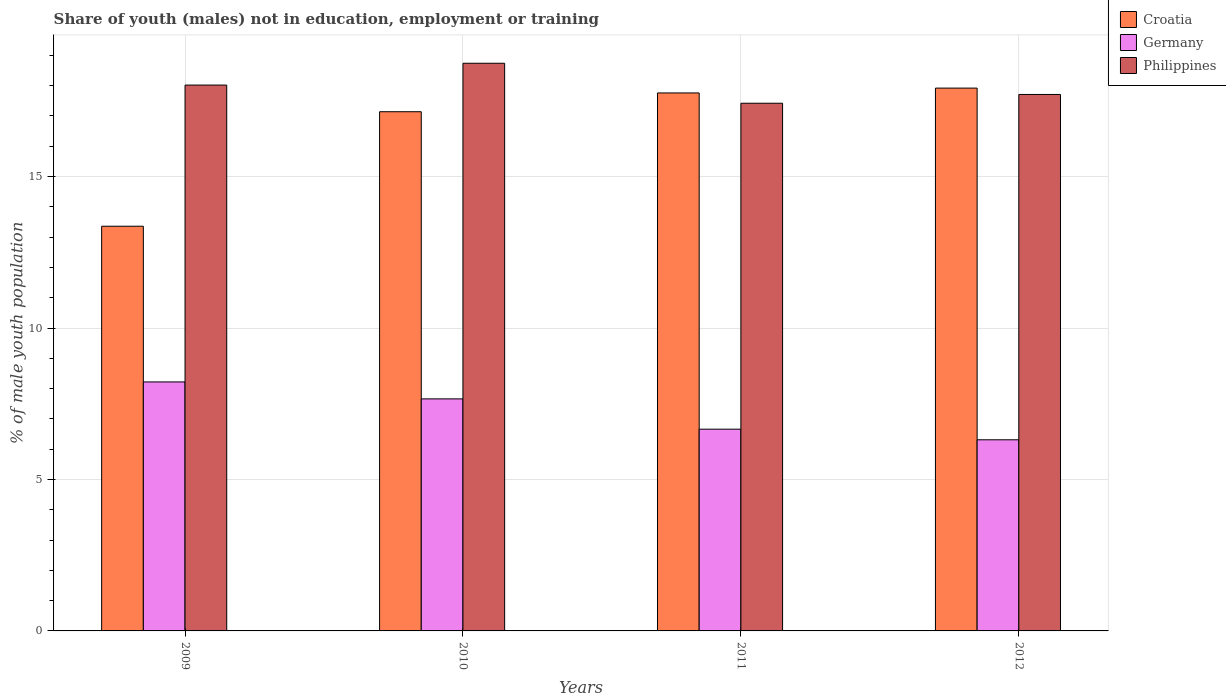Are the number of bars on each tick of the X-axis equal?
Make the answer very short. Yes. How many bars are there on the 3rd tick from the left?
Your answer should be compact. 3. In how many cases, is the number of bars for a given year not equal to the number of legend labels?
Give a very brief answer. 0. What is the percentage of unemployed males population in in Croatia in 2010?
Make the answer very short. 17.14. Across all years, what is the maximum percentage of unemployed males population in in Croatia?
Keep it short and to the point. 17.92. Across all years, what is the minimum percentage of unemployed males population in in Philippines?
Your answer should be compact. 17.42. In which year was the percentage of unemployed males population in in Philippines maximum?
Your answer should be compact. 2010. In which year was the percentage of unemployed males population in in Croatia minimum?
Provide a short and direct response. 2009. What is the total percentage of unemployed males population in in Croatia in the graph?
Provide a succinct answer. 66.18. What is the difference between the percentage of unemployed males population in in Philippines in 2010 and that in 2011?
Give a very brief answer. 1.32. What is the difference between the percentage of unemployed males population in in Croatia in 2011 and the percentage of unemployed males population in in Germany in 2010?
Give a very brief answer. 10.1. What is the average percentage of unemployed males population in in Philippines per year?
Provide a succinct answer. 17.97. In the year 2011, what is the difference between the percentage of unemployed males population in in Germany and percentage of unemployed males population in in Philippines?
Provide a short and direct response. -10.76. What is the ratio of the percentage of unemployed males population in in Croatia in 2009 to that in 2011?
Give a very brief answer. 0.75. Is the difference between the percentage of unemployed males population in in Germany in 2009 and 2010 greater than the difference between the percentage of unemployed males population in in Philippines in 2009 and 2010?
Provide a succinct answer. Yes. What is the difference between the highest and the second highest percentage of unemployed males population in in Germany?
Make the answer very short. 0.56. What is the difference between the highest and the lowest percentage of unemployed males population in in Croatia?
Keep it short and to the point. 4.56. What does the 3rd bar from the right in 2012 represents?
Offer a very short reply. Croatia. How many bars are there?
Offer a very short reply. 12. Are all the bars in the graph horizontal?
Your response must be concise. No. How many years are there in the graph?
Your answer should be very brief. 4. What is the difference between two consecutive major ticks on the Y-axis?
Your answer should be compact. 5. Does the graph contain grids?
Offer a terse response. Yes. Where does the legend appear in the graph?
Offer a very short reply. Top right. How many legend labels are there?
Offer a very short reply. 3. How are the legend labels stacked?
Provide a succinct answer. Vertical. What is the title of the graph?
Make the answer very short. Share of youth (males) not in education, employment or training. What is the label or title of the X-axis?
Ensure brevity in your answer.  Years. What is the label or title of the Y-axis?
Offer a very short reply. % of male youth population. What is the % of male youth population in Croatia in 2009?
Offer a very short reply. 13.36. What is the % of male youth population of Germany in 2009?
Your answer should be very brief. 8.22. What is the % of male youth population of Philippines in 2009?
Offer a very short reply. 18.02. What is the % of male youth population of Croatia in 2010?
Offer a very short reply. 17.14. What is the % of male youth population in Germany in 2010?
Your answer should be very brief. 7.66. What is the % of male youth population of Philippines in 2010?
Keep it short and to the point. 18.74. What is the % of male youth population of Croatia in 2011?
Give a very brief answer. 17.76. What is the % of male youth population in Germany in 2011?
Offer a very short reply. 6.66. What is the % of male youth population in Philippines in 2011?
Offer a terse response. 17.42. What is the % of male youth population of Croatia in 2012?
Offer a very short reply. 17.92. What is the % of male youth population of Germany in 2012?
Provide a short and direct response. 6.31. What is the % of male youth population in Philippines in 2012?
Ensure brevity in your answer.  17.71. Across all years, what is the maximum % of male youth population of Croatia?
Make the answer very short. 17.92. Across all years, what is the maximum % of male youth population of Germany?
Give a very brief answer. 8.22. Across all years, what is the maximum % of male youth population of Philippines?
Your answer should be compact. 18.74. Across all years, what is the minimum % of male youth population in Croatia?
Ensure brevity in your answer.  13.36. Across all years, what is the minimum % of male youth population in Germany?
Provide a short and direct response. 6.31. Across all years, what is the minimum % of male youth population in Philippines?
Give a very brief answer. 17.42. What is the total % of male youth population of Croatia in the graph?
Give a very brief answer. 66.18. What is the total % of male youth population in Germany in the graph?
Provide a short and direct response. 28.85. What is the total % of male youth population in Philippines in the graph?
Your answer should be very brief. 71.89. What is the difference between the % of male youth population in Croatia in 2009 and that in 2010?
Ensure brevity in your answer.  -3.78. What is the difference between the % of male youth population in Germany in 2009 and that in 2010?
Offer a terse response. 0.56. What is the difference between the % of male youth population in Philippines in 2009 and that in 2010?
Offer a terse response. -0.72. What is the difference between the % of male youth population of Croatia in 2009 and that in 2011?
Offer a terse response. -4.4. What is the difference between the % of male youth population of Germany in 2009 and that in 2011?
Your answer should be compact. 1.56. What is the difference between the % of male youth population in Philippines in 2009 and that in 2011?
Give a very brief answer. 0.6. What is the difference between the % of male youth population of Croatia in 2009 and that in 2012?
Provide a short and direct response. -4.56. What is the difference between the % of male youth population of Germany in 2009 and that in 2012?
Your answer should be very brief. 1.91. What is the difference between the % of male youth population in Philippines in 2009 and that in 2012?
Offer a very short reply. 0.31. What is the difference between the % of male youth population of Croatia in 2010 and that in 2011?
Ensure brevity in your answer.  -0.62. What is the difference between the % of male youth population in Germany in 2010 and that in 2011?
Your answer should be compact. 1. What is the difference between the % of male youth population in Philippines in 2010 and that in 2011?
Make the answer very short. 1.32. What is the difference between the % of male youth population of Croatia in 2010 and that in 2012?
Make the answer very short. -0.78. What is the difference between the % of male youth population of Germany in 2010 and that in 2012?
Ensure brevity in your answer.  1.35. What is the difference between the % of male youth population in Croatia in 2011 and that in 2012?
Offer a terse response. -0.16. What is the difference between the % of male youth population in Germany in 2011 and that in 2012?
Your answer should be very brief. 0.35. What is the difference between the % of male youth population of Philippines in 2011 and that in 2012?
Your answer should be compact. -0.29. What is the difference between the % of male youth population in Croatia in 2009 and the % of male youth population in Philippines in 2010?
Offer a terse response. -5.38. What is the difference between the % of male youth population in Germany in 2009 and the % of male youth population in Philippines in 2010?
Give a very brief answer. -10.52. What is the difference between the % of male youth population of Croatia in 2009 and the % of male youth population of Germany in 2011?
Offer a terse response. 6.7. What is the difference between the % of male youth population of Croatia in 2009 and the % of male youth population of Philippines in 2011?
Make the answer very short. -4.06. What is the difference between the % of male youth population of Germany in 2009 and the % of male youth population of Philippines in 2011?
Offer a terse response. -9.2. What is the difference between the % of male youth population in Croatia in 2009 and the % of male youth population in Germany in 2012?
Ensure brevity in your answer.  7.05. What is the difference between the % of male youth population in Croatia in 2009 and the % of male youth population in Philippines in 2012?
Offer a very short reply. -4.35. What is the difference between the % of male youth population of Germany in 2009 and the % of male youth population of Philippines in 2012?
Give a very brief answer. -9.49. What is the difference between the % of male youth population in Croatia in 2010 and the % of male youth population in Germany in 2011?
Offer a very short reply. 10.48. What is the difference between the % of male youth population in Croatia in 2010 and the % of male youth population in Philippines in 2011?
Make the answer very short. -0.28. What is the difference between the % of male youth population in Germany in 2010 and the % of male youth population in Philippines in 2011?
Your answer should be compact. -9.76. What is the difference between the % of male youth population of Croatia in 2010 and the % of male youth population of Germany in 2012?
Make the answer very short. 10.83. What is the difference between the % of male youth population in Croatia in 2010 and the % of male youth population in Philippines in 2012?
Make the answer very short. -0.57. What is the difference between the % of male youth population of Germany in 2010 and the % of male youth population of Philippines in 2012?
Provide a short and direct response. -10.05. What is the difference between the % of male youth population in Croatia in 2011 and the % of male youth population in Germany in 2012?
Provide a short and direct response. 11.45. What is the difference between the % of male youth population in Germany in 2011 and the % of male youth population in Philippines in 2012?
Make the answer very short. -11.05. What is the average % of male youth population in Croatia per year?
Give a very brief answer. 16.55. What is the average % of male youth population of Germany per year?
Give a very brief answer. 7.21. What is the average % of male youth population of Philippines per year?
Keep it short and to the point. 17.97. In the year 2009, what is the difference between the % of male youth population of Croatia and % of male youth population of Germany?
Make the answer very short. 5.14. In the year 2009, what is the difference between the % of male youth population of Croatia and % of male youth population of Philippines?
Make the answer very short. -4.66. In the year 2009, what is the difference between the % of male youth population of Germany and % of male youth population of Philippines?
Keep it short and to the point. -9.8. In the year 2010, what is the difference between the % of male youth population of Croatia and % of male youth population of Germany?
Provide a short and direct response. 9.48. In the year 2010, what is the difference between the % of male youth population in Croatia and % of male youth population in Philippines?
Your response must be concise. -1.6. In the year 2010, what is the difference between the % of male youth population of Germany and % of male youth population of Philippines?
Give a very brief answer. -11.08. In the year 2011, what is the difference between the % of male youth population in Croatia and % of male youth population in Germany?
Your response must be concise. 11.1. In the year 2011, what is the difference between the % of male youth population in Croatia and % of male youth population in Philippines?
Make the answer very short. 0.34. In the year 2011, what is the difference between the % of male youth population in Germany and % of male youth population in Philippines?
Your answer should be very brief. -10.76. In the year 2012, what is the difference between the % of male youth population of Croatia and % of male youth population of Germany?
Ensure brevity in your answer.  11.61. In the year 2012, what is the difference between the % of male youth population in Croatia and % of male youth population in Philippines?
Your answer should be compact. 0.21. What is the ratio of the % of male youth population of Croatia in 2009 to that in 2010?
Make the answer very short. 0.78. What is the ratio of the % of male youth population in Germany in 2009 to that in 2010?
Your answer should be very brief. 1.07. What is the ratio of the % of male youth population of Philippines in 2009 to that in 2010?
Provide a succinct answer. 0.96. What is the ratio of the % of male youth population in Croatia in 2009 to that in 2011?
Give a very brief answer. 0.75. What is the ratio of the % of male youth population of Germany in 2009 to that in 2011?
Keep it short and to the point. 1.23. What is the ratio of the % of male youth population of Philippines in 2009 to that in 2011?
Provide a succinct answer. 1.03. What is the ratio of the % of male youth population of Croatia in 2009 to that in 2012?
Keep it short and to the point. 0.75. What is the ratio of the % of male youth population of Germany in 2009 to that in 2012?
Your answer should be very brief. 1.3. What is the ratio of the % of male youth population of Philippines in 2009 to that in 2012?
Make the answer very short. 1.02. What is the ratio of the % of male youth population of Croatia in 2010 to that in 2011?
Make the answer very short. 0.97. What is the ratio of the % of male youth population in Germany in 2010 to that in 2011?
Your response must be concise. 1.15. What is the ratio of the % of male youth population in Philippines in 2010 to that in 2011?
Your answer should be very brief. 1.08. What is the ratio of the % of male youth population in Croatia in 2010 to that in 2012?
Make the answer very short. 0.96. What is the ratio of the % of male youth population in Germany in 2010 to that in 2012?
Your response must be concise. 1.21. What is the ratio of the % of male youth population in Philippines in 2010 to that in 2012?
Offer a very short reply. 1.06. What is the ratio of the % of male youth population in Germany in 2011 to that in 2012?
Ensure brevity in your answer.  1.06. What is the ratio of the % of male youth population of Philippines in 2011 to that in 2012?
Offer a terse response. 0.98. What is the difference between the highest and the second highest % of male youth population of Croatia?
Your answer should be compact. 0.16. What is the difference between the highest and the second highest % of male youth population in Germany?
Keep it short and to the point. 0.56. What is the difference between the highest and the second highest % of male youth population of Philippines?
Offer a terse response. 0.72. What is the difference between the highest and the lowest % of male youth population in Croatia?
Offer a terse response. 4.56. What is the difference between the highest and the lowest % of male youth population in Germany?
Offer a terse response. 1.91. What is the difference between the highest and the lowest % of male youth population in Philippines?
Offer a terse response. 1.32. 